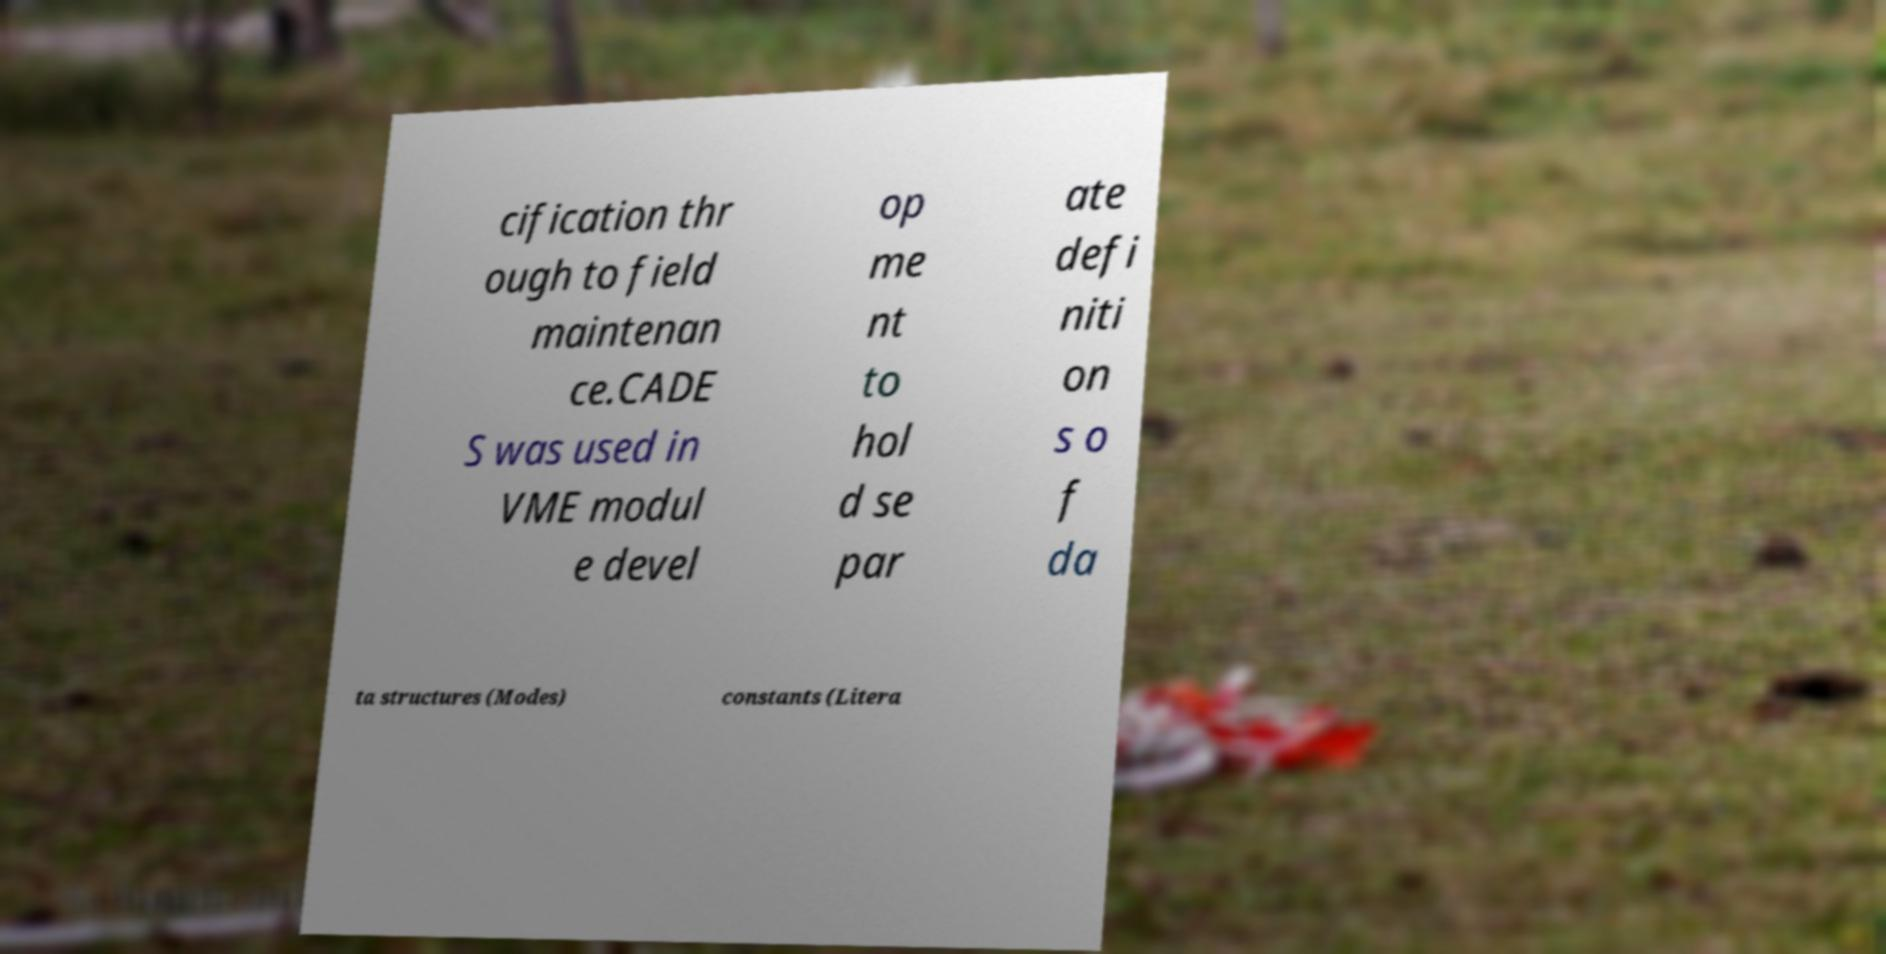Could you extract and type out the text from this image? cification thr ough to field maintenan ce.CADE S was used in VME modul e devel op me nt to hol d se par ate defi niti on s o f da ta structures (Modes) constants (Litera 